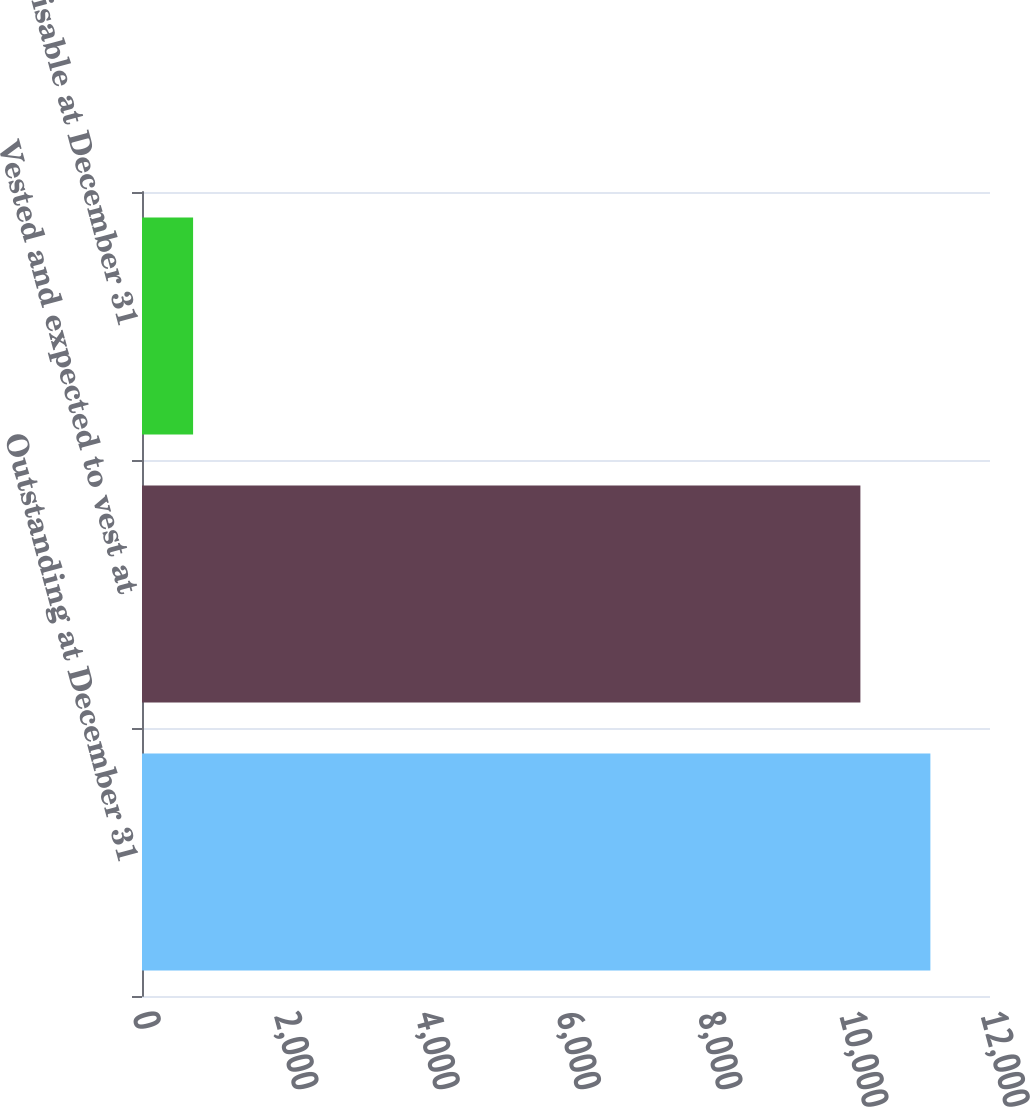<chart> <loc_0><loc_0><loc_500><loc_500><bar_chart><fcel>Outstanding at December 31<fcel>Vested and expected to vest at<fcel>Exercisable at December 31<nl><fcel>11156.4<fcel>10166<fcel>723<nl></chart> 